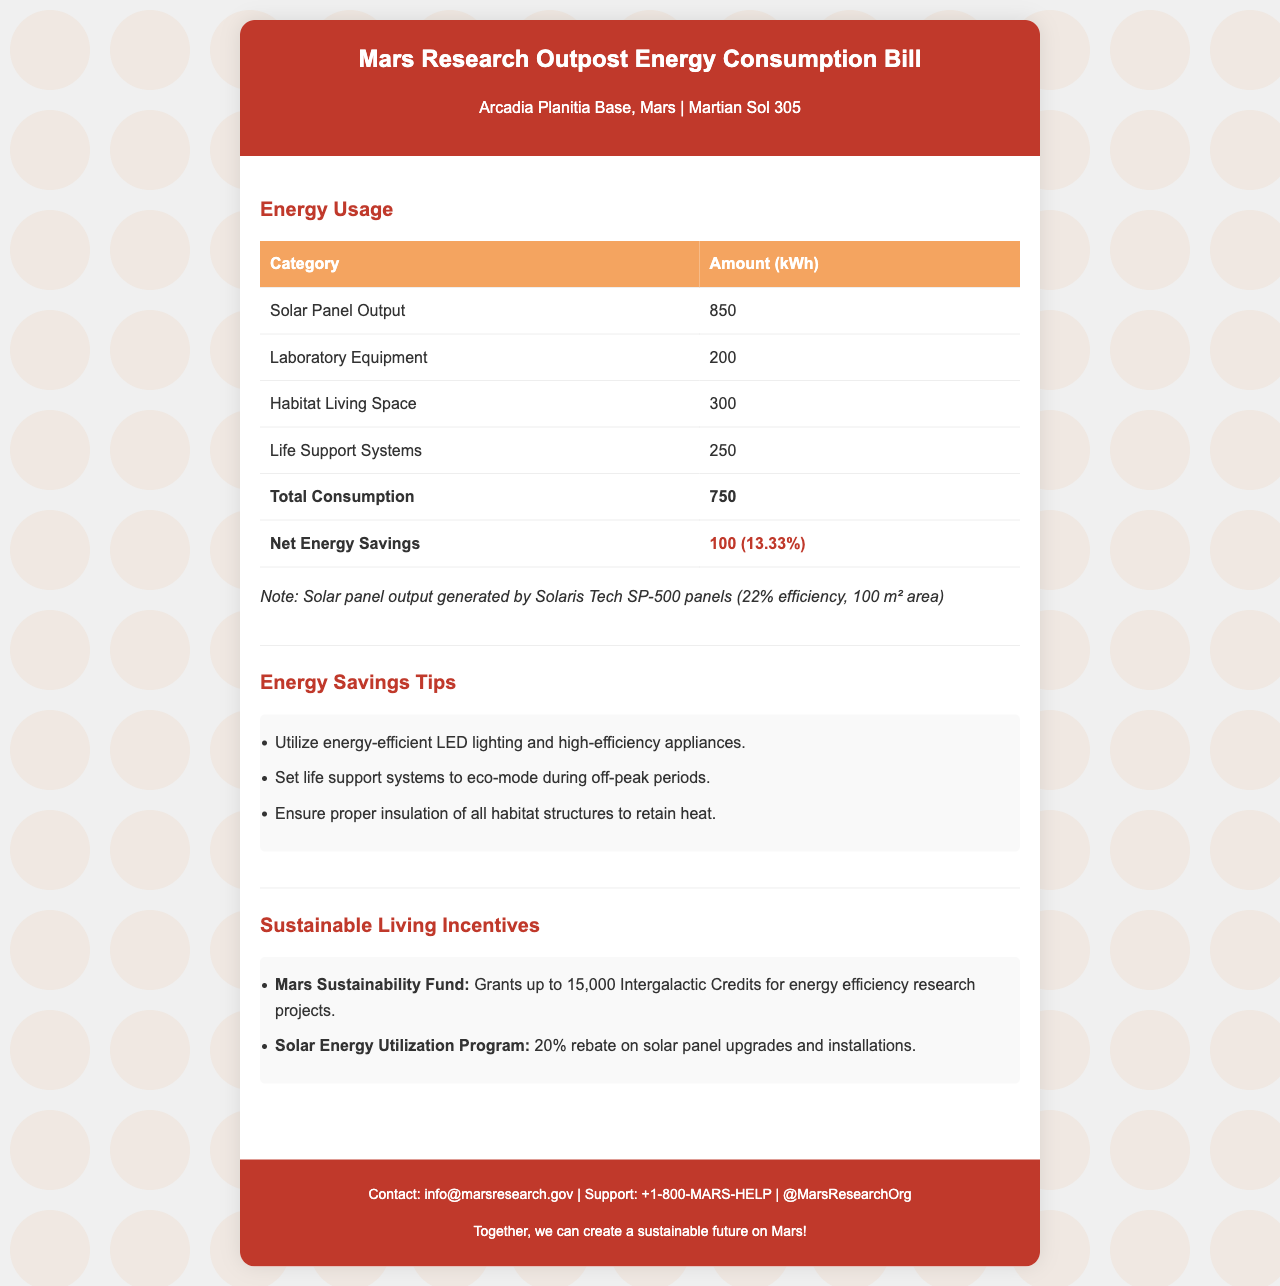What is the total consumption? The total consumption is listed in the energy usage table under the total consumption row.
Answer: 750 What is the solar panel output? The solar panel output is specified in the energy usage table.
Answer: 850 What percentage of net energy savings is indicated? The percentage of net energy savings is shown next to the net energy savings amount in the energy usage section.
Answer: 13.33% What is the maximum grant available from the Mars Sustainability Fund? The maximum grant amount is specified in the sustainable living incentives section.
Answer: 15,000 Intergalactic Credits Which mode should life support systems be set to during off-peak periods? This information is given in the energy savings tips section.
Answer: Eco-mode How much rebate is offered for solar panel upgrades and installations? The rebate amount is detailed in the sustainable living incentives.
Answer: 20% What is the efficiency percentage of the solar panels used? The efficiency percentage is mentioned in the note about the solar panel output.
Answer: 22% What are the main components consuming energy in the habitat? The components are listed in the energy usage section of the document.
Answer: Laboratory Equipment, Habitat Living Space, Life Support Systems 